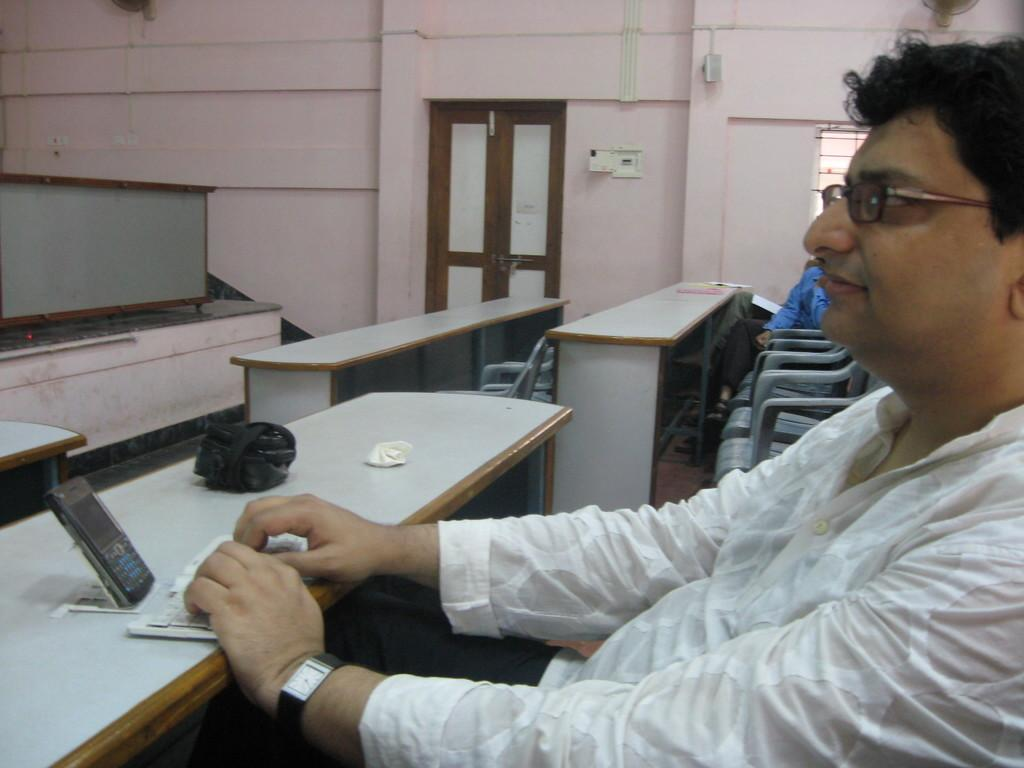Who is present in the image? There is a person in the image. What is the person wearing? The person is wearing a white shirt. What is the person doing in the image? The person is typing something. What can be seen in the background of the image? There is a door and a wall in the background of the image. What type of picture can be seen hanging on the wall in the image? There is no picture hanging on the wall in the image; only a door and a wall are visible in the background. 